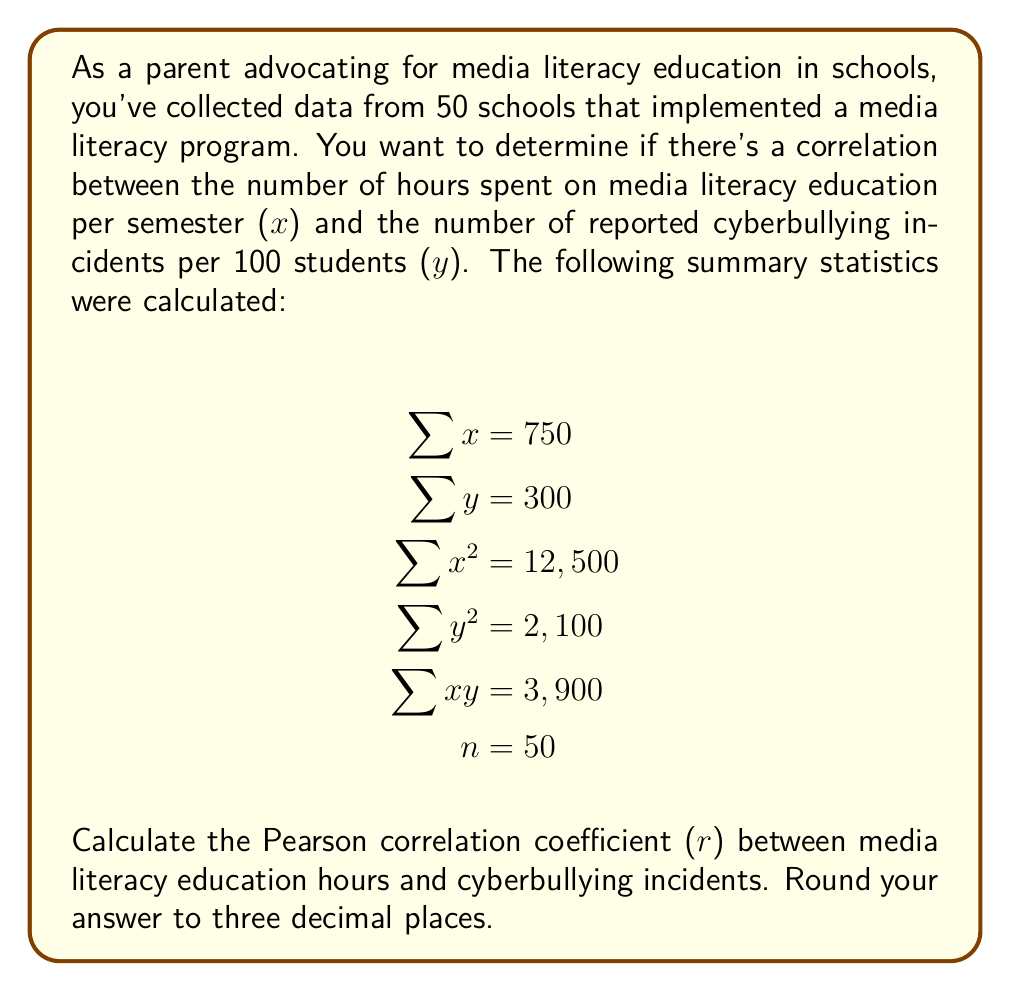Teach me how to tackle this problem. To calculate the Pearson correlation coefficient (r), we'll use the formula:

$$ r = \frac{n\sum xy - \sum x \sum y}{\sqrt{[n\sum x^2 - (\sum x)^2][n\sum y^2 - (\sum y)^2]}} $$

Let's substitute the given values:

$n = 50$
$\sum x = 750$
$\sum y = 300$
$\sum x^2 = 12,500$
$\sum y^2 = 2,100$
$\sum xy = 3,900$

Step 1: Calculate $n\sum xy$
$50 \times 3,900 = 195,000$

Step 2: Calculate $\sum x \sum y$
$750 \times 300 = 225,000$

Step 3: Calculate the numerator
$195,000 - 225,000 = -30,000$

Step 4: Calculate $n\sum x^2$ and $(\sum x)^2$
$n\sum x^2 = 50 \times 12,500 = 625,000$
$(\sum x)^2 = 750^2 = 562,500$

Step 5: Calculate $n\sum y^2$ and $(\sum y)^2$
$n\sum y^2 = 50 \times 2,100 = 105,000$
$(\sum y)^2 = 300^2 = 90,000$

Step 6: Calculate the denominator
$\sqrt{[625,000 - 562,500][105,000 - 90,000]}$
$= \sqrt{[62,500][15,000]}$
$= \sqrt{937,500,000}$
$= 30,619.55$

Step 7: Divide the numerator by the denominator
$r = \frac{-30,000}{30,619.55} = -0.9797$

Step 8: Round to three decimal places
$r = -0.980$
Answer: $r = -0.980$ 